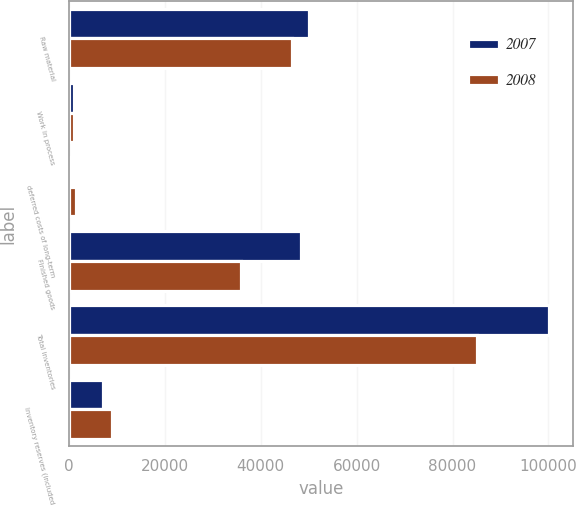Convert chart to OTSL. <chart><loc_0><loc_0><loc_500><loc_500><stacked_bar_chart><ecel><fcel>Raw material<fcel>Work in process<fcel>deferred costs of long-term<fcel>Finished goods<fcel>Total inventories<fcel>Inventory reserves (included<nl><fcel>2007<fcel>50015<fcel>1130<fcel>628<fcel>48426<fcel>100199<fcel>7172<nl><fcel>2008<fcel>46572<fcel>1103<fcel>1469<fcel>35894<fcel>85038<fcel>8999<nl></chart> 